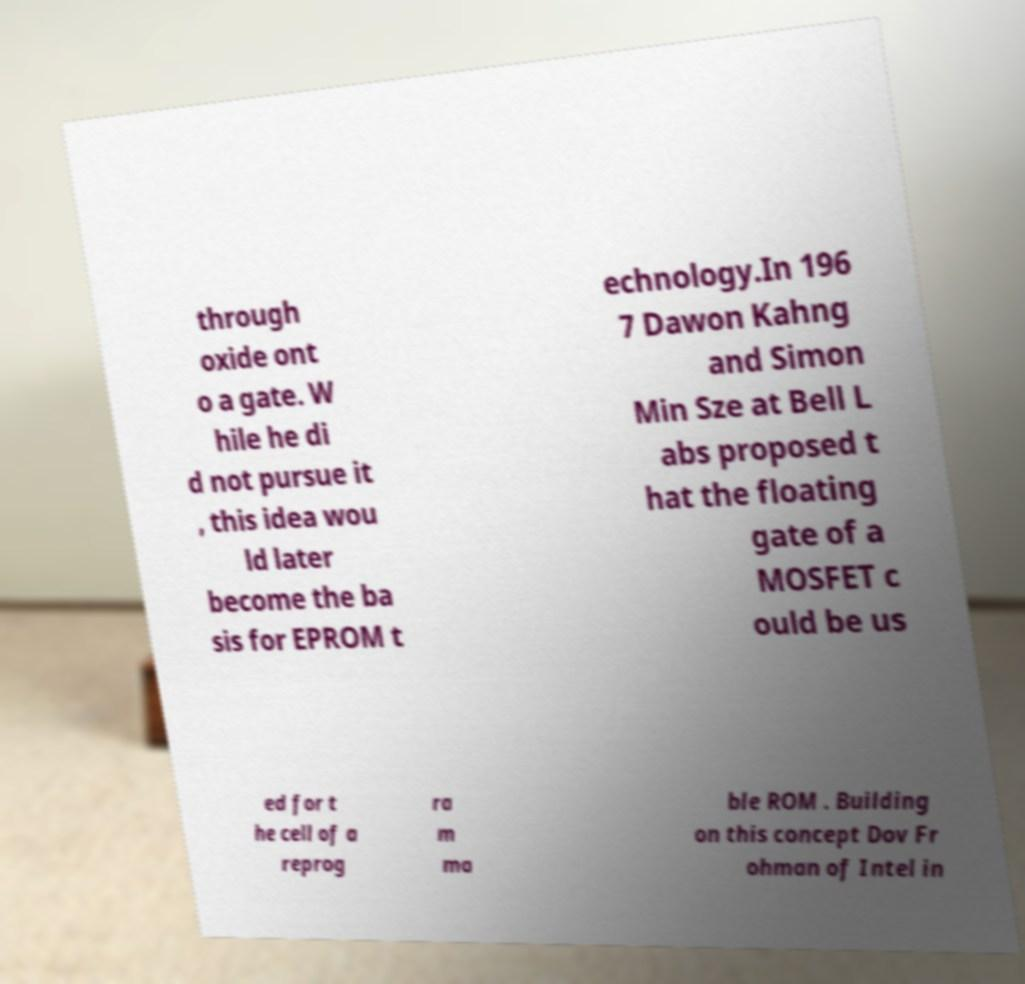Can you accurately transcribe the text from the provided image for me? through oxide ont o a gate. W hile he di d not pursue it , this idea wou ld later become the ba sis for EPROM t echnology.In 196 7 Dawon Kahng and Simon Min Sze at Bell L abs proposed t hat the floating gate of a MOSFET c ould be us ed for t he cell of a reprog ra m ma ble ROM . Building on this concept Dov Fr ohman of Intel in 